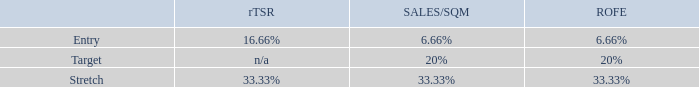It rewards executives subject to performance against three equally weighted measures over a three year performance period:
Relative TSR is used as a measure in our LTI plan to align executive outcomes and long‐term shareholder value creation. The peer group is the ASX30 excluding metals and mining companies. Peer group ranking at the 75th percentile or higher 100% vesting is achieved and ranking at the median 50% vesting is achieved. Between the 75th  and median, pro-rata vesting is achieved from 50% to 100%. Peer group ranking below the median results in zero vesting.
Sales per square metre measures sales productivity improvements across the Food and Drinks businesses. Efficient use of our physical network for in‐store and online sales is core to our success.
ROFE is an important measures to drive behaviours consistent with the delivery of long‐term shareholder value. ROFE improvements can be delivered through earnings growth as well as the disciplined allocation of capital and management of assets, which is important for a business that is building capabilities for the future. Lease‐adjusted ROFE measures the balance between our earnings growth and the disciplined allocation and application of assets used to generate those earnings. We adjust for leases to recognise that a very significant portion of our sites are leased. This approach is also similar to the accounting standard definition of ROFE that will change to incorporate a lease-adjusted definition from F20.
The Sales/SQM and ROFE targets are published following the end of the performance period given the commercial sensitivity of this information.
What does the lease-adjusted ROFE measure? Measures the balance between our earnings growth and the disciplined allocation and application of assets used to generate those earnings. What is the rTSR for Entry? 16.66%. What does the Sales per square metre measure? Measures sales productivity improvements across the food and drinks businesses. What is the total SALES/SQM for all 3 levels?
Answer scale should be: percent. 6.66% + 20% + 33.33% 
Answer: 59.99. What is the difference for rTSR between Stretch and Entry?
Answer scale should be: percent. 33.33% - 16.66% 
Answer: 16.67. What is the total ROFE across all 3 levels?
Answer scale should be: percent. 6.66% + 20% + 33.33% 
Answer: 59.99. 